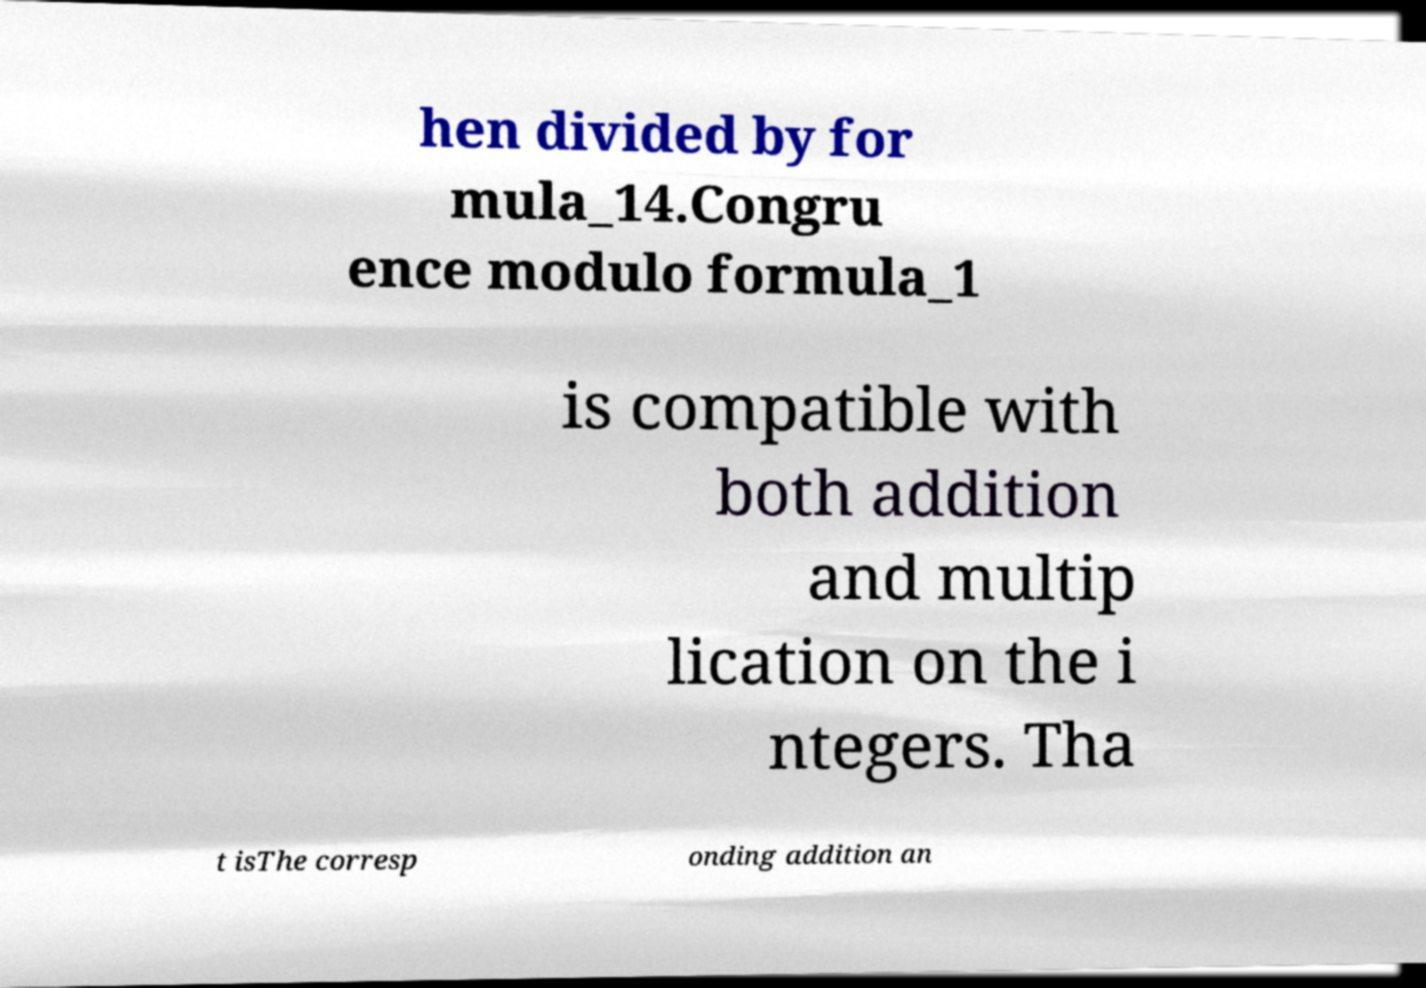I need the written content from this picture converted into text. Can you do that? hen divided by for mula_14.Congru ence modulo formula_1 is compatible with both addition and multip lication on the i ntegers. Tha t isThe corresp onding addition an 